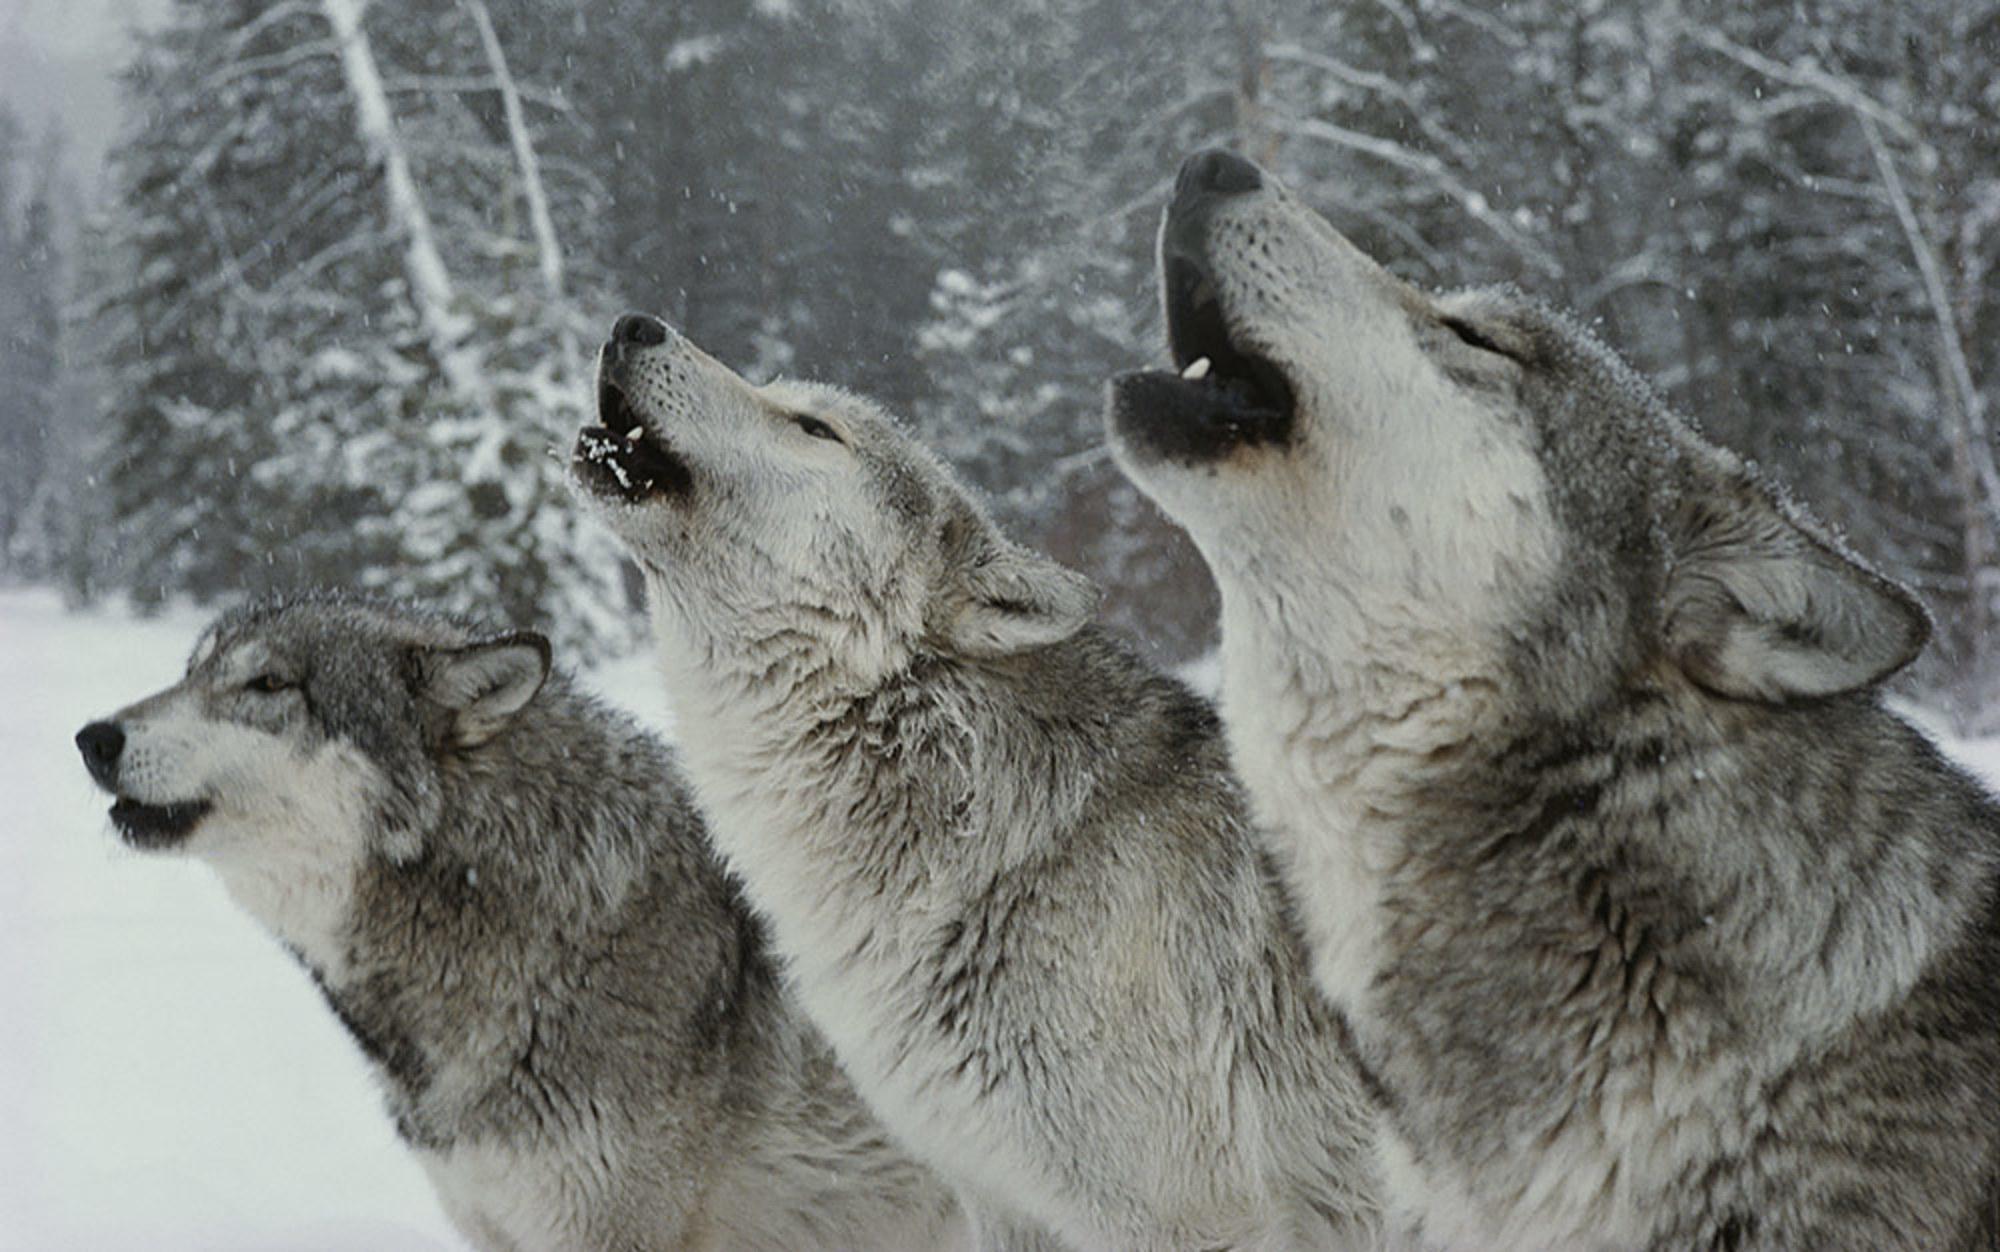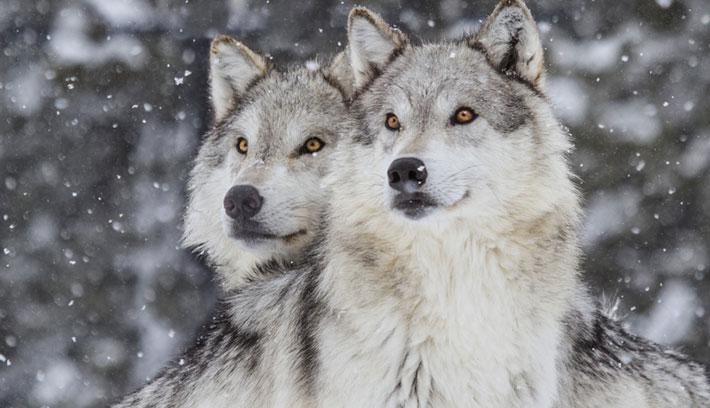The first image is the image on the left, the second image is the image on the right. Evaluate the accuracy of this statement regarding the images: "There are exactly three wolves standing next to each-other in the image on the left.". Is it true? Answer yes or no. Yes. The first image is the image on the left, the second image is the image on the right. Examine the images to the left and right. Is the description "An image shows a row of three wolves with heads that are not raised high, and two of the wolves have open mouths." accurate? Answer yes or no. No. 